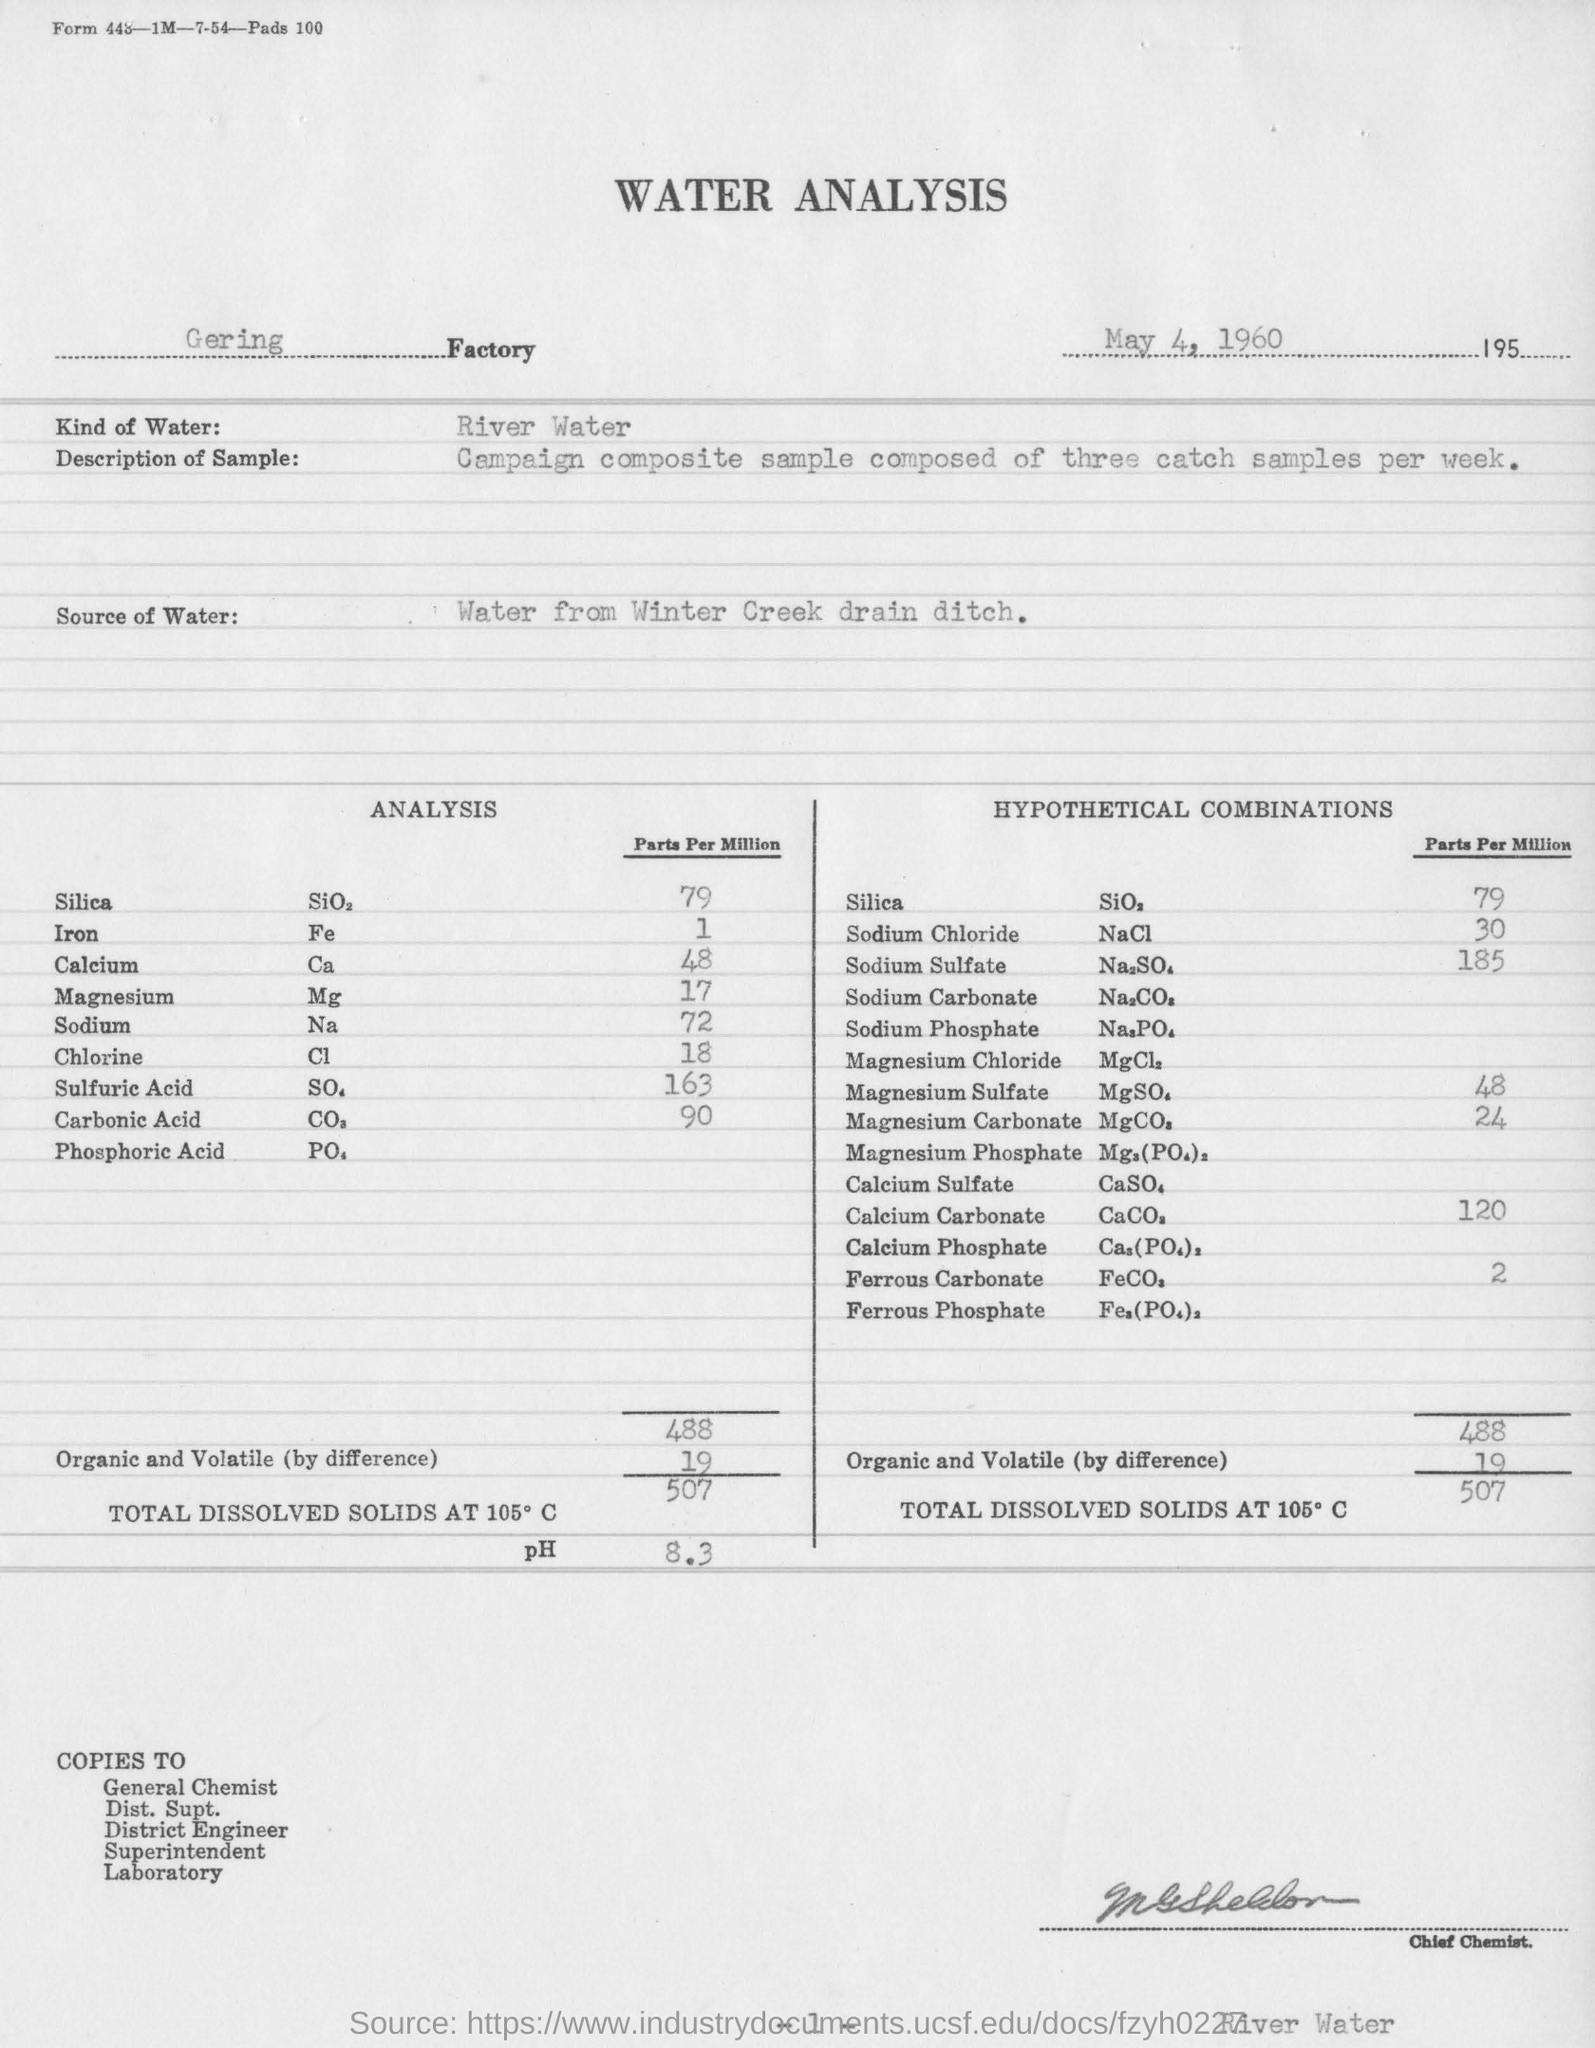Outline some significant characteristics in this image. The water analysis was conducted on May 4, 1960. River water is typically used in water analysis. Magnesium sulfate occurs in trace amounts in hypothetical combinations. The parts per million value of magnesium sulfate in these combinations is 48. In hypothetical combinations, the parts per million value of sodium sulfate is approximately 185. In hypothetical combinations, the parts per million value of magnesium carbonate could reach X. 